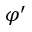Convert formula to latex. <formula><loc_0><loc_0><loc_500><loc_500>\varphi ^ { \prime }</formula> 